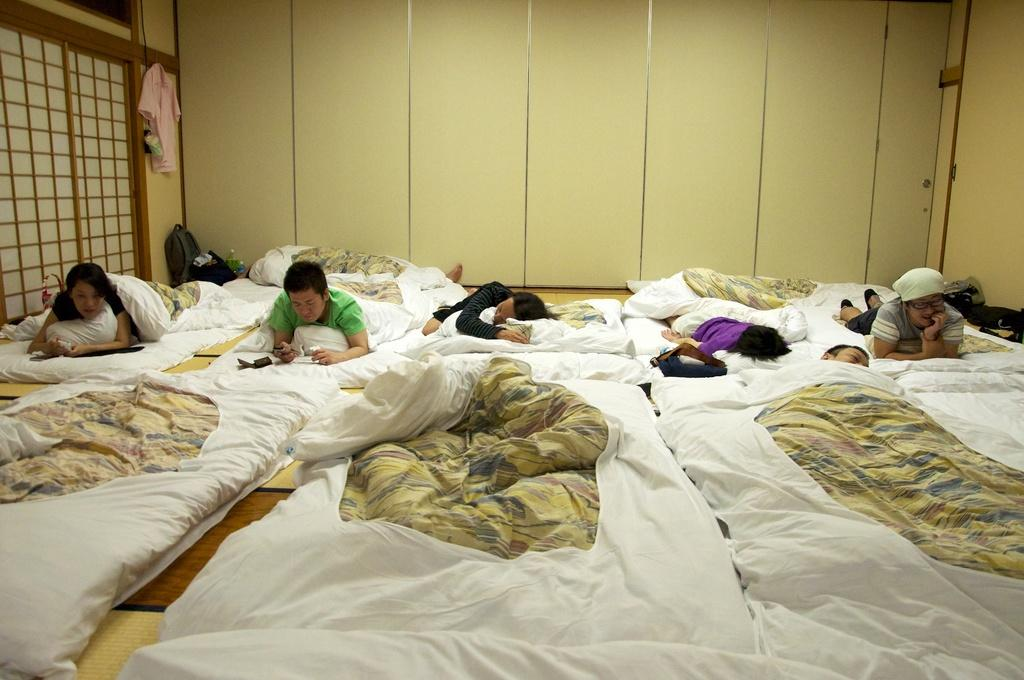Where was the image taken? The image was taken inside a room. What type of furniture is present in the room? There are beds in the room. What is covering the beds? There are blankets on the beds. What are the people in the image doing? People are lying on the beds. What clothing item can be seen on the left side of the room? There is a dress on the left side of the room. What personal items are present in the room? There are bags and water bottles in the room. What type of steel structure can be seen in the image? There is no steel structure present in the image. How does the dress turn into a different color in the image? The dress does not change color or turn into anything else in the image; it remains a dress. 